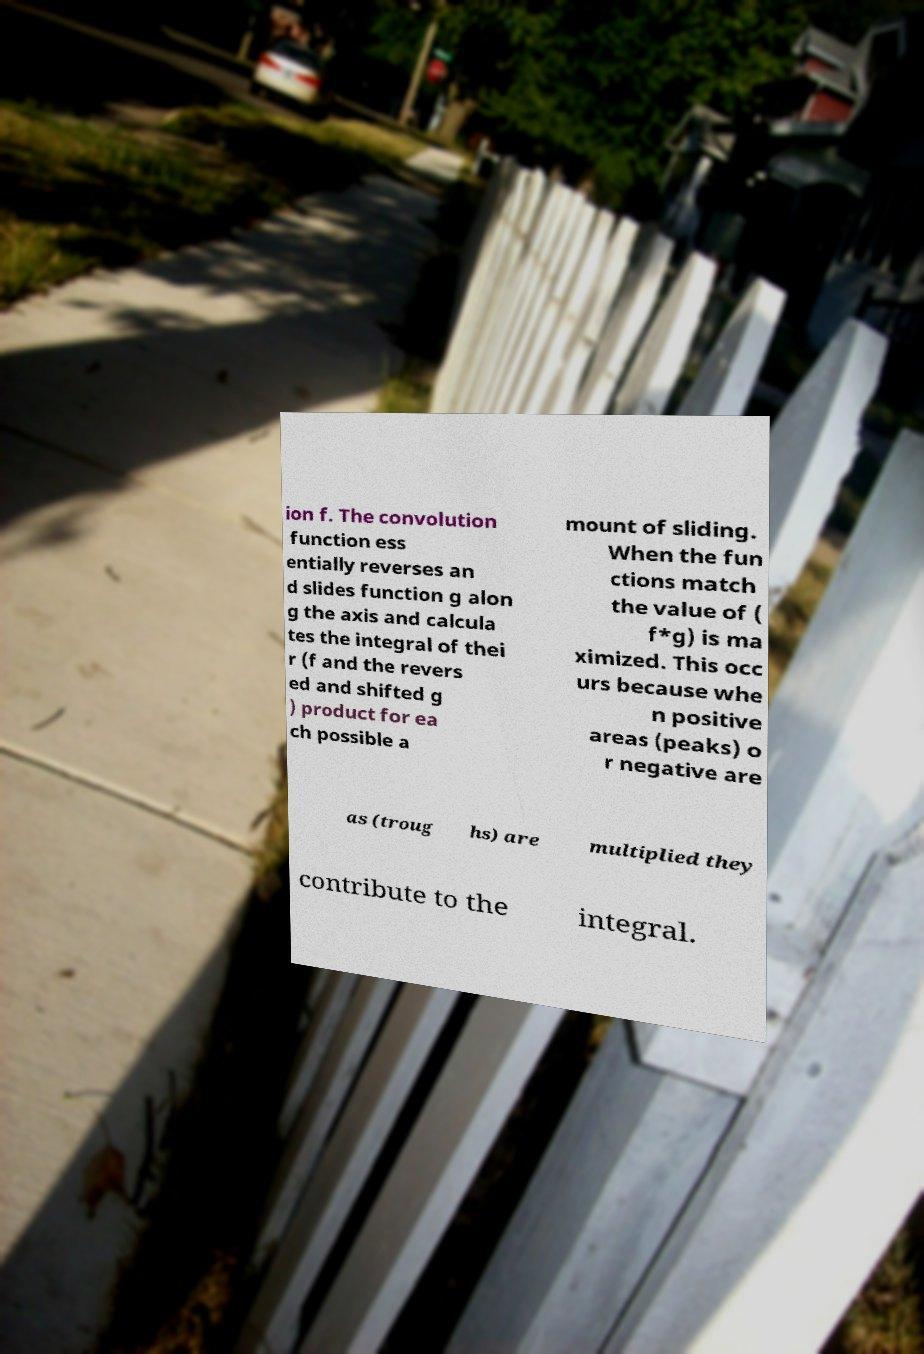Can you accurately transcribe the text from the provided image for me? ion f. The convolution function ess entially reverses an d slides function g alon g the axis and calcula tes the integral of thei r (f and the revers ed and shifted g ) product for ea ch possible a mount of sliding. When the fun ctions match the value of ( f*g) is ma ximized. This occ urs because whe n positive areas (peaks) o r negative are as (troug hs) are multiplied they contribute to the integral. 